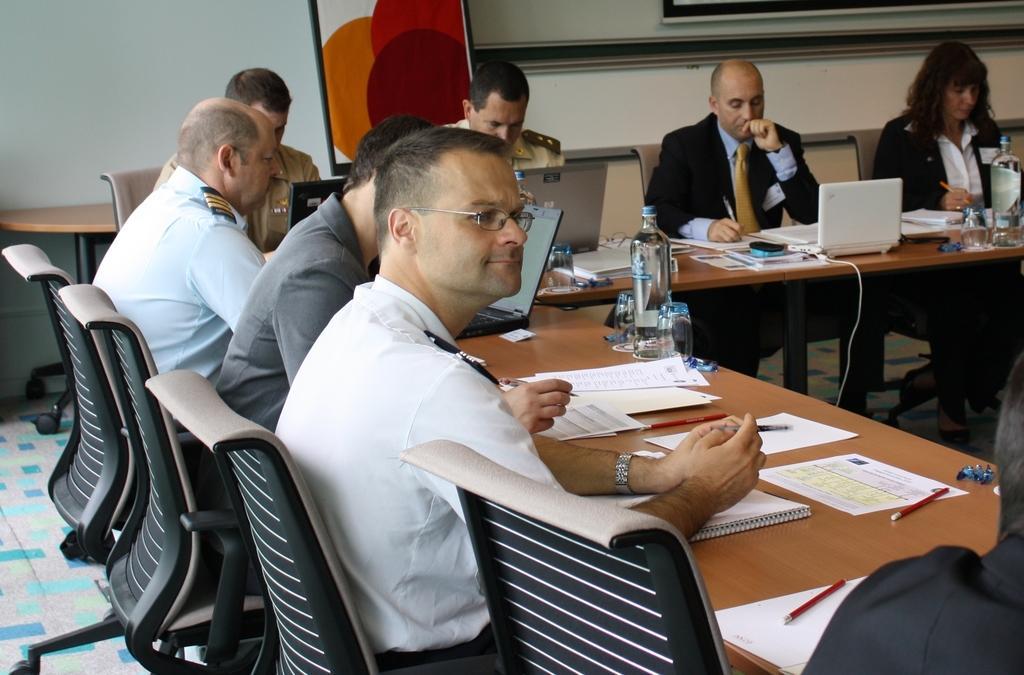Could you give a brief overview of what you see in this image? In this picture we can see a group of people sitting on chair and in front of them there is table and on table we can see book, paper, pencil, bottles, laptop, wires and in background we can see wall. 